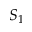Convert formula to latex. <formula><loc_0><loc_0><loc_500><loc_500>S _ { 1 }</formula> 